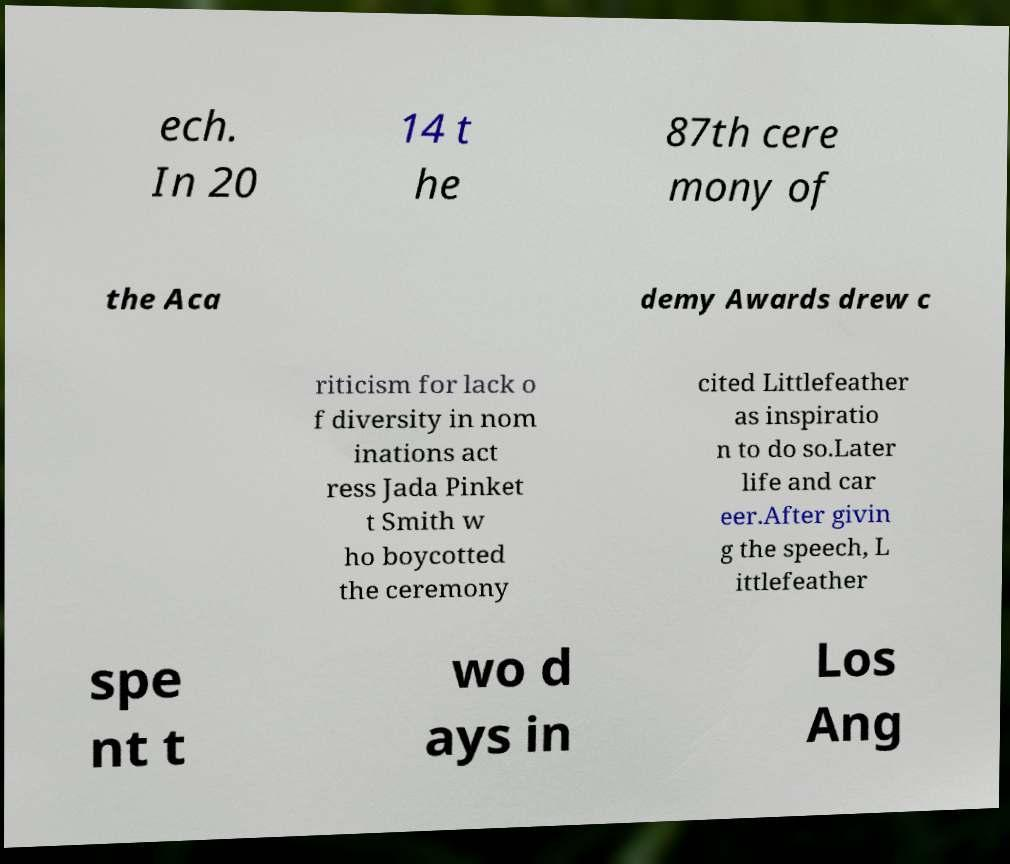Could you assist in decoding the text presented in this image and type it out clearly? ech. In 20 14 t he 87th cere mony of the Aca demy Awards drew c riticism for lack o f diversity in nom inations act ress Jada Pinket t Smith w ho boycotted the ceremony cited Littlefeather as inspiratio n to do so.Later life and car eer.After givin g the speech, L ittlefeather spe nt t wo d ays in Los Ang 